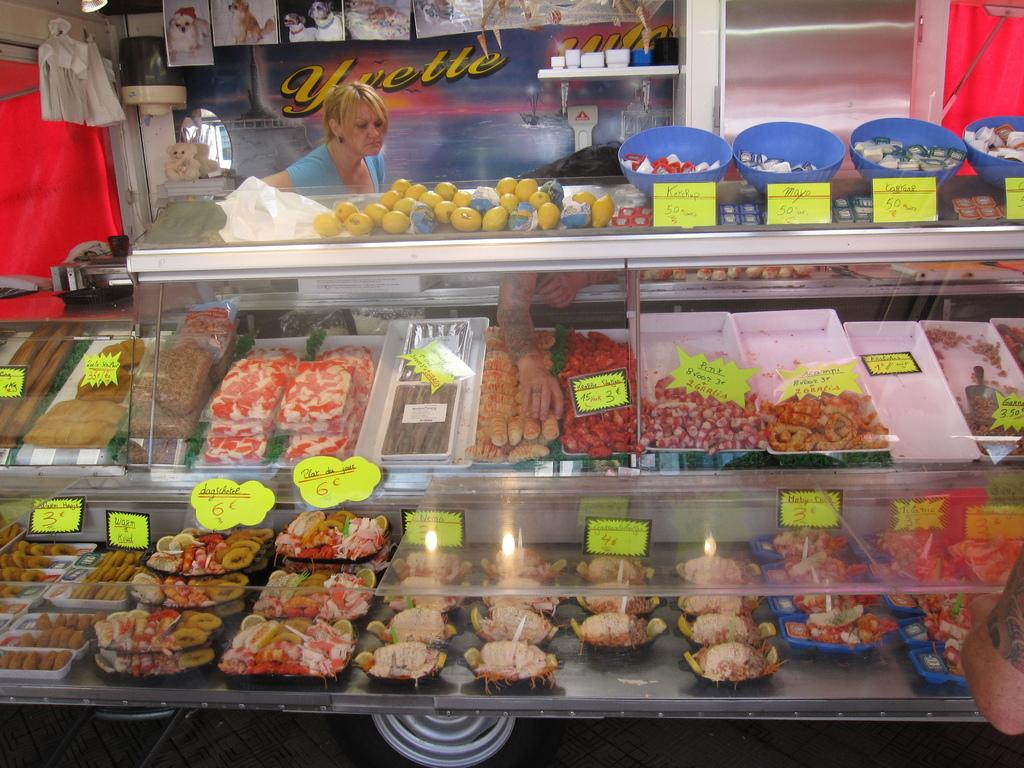Provide a one-sentence caption for the provided image. A large deli case is in front of a sign with Yvette written on it. 